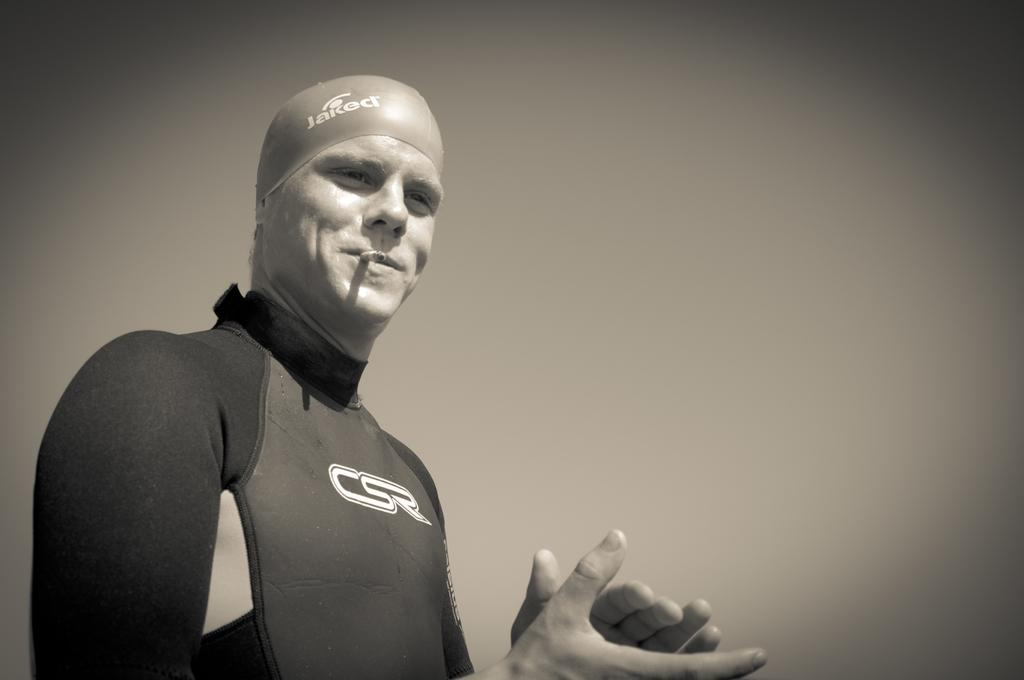What is the main subject of the image? There is a person standing in the image. What is the person wearing? The person is wearing a dress. Can you describe any other objects in the image? A cigarette is visible in the image. What is the color scheme of the image? The image is in black and white. What is the person's belief about taxation in the image? There is no information about the person's beliefs or opinions on taxation in the image. How many cats are present in the image? There are no cats visible in the image. 